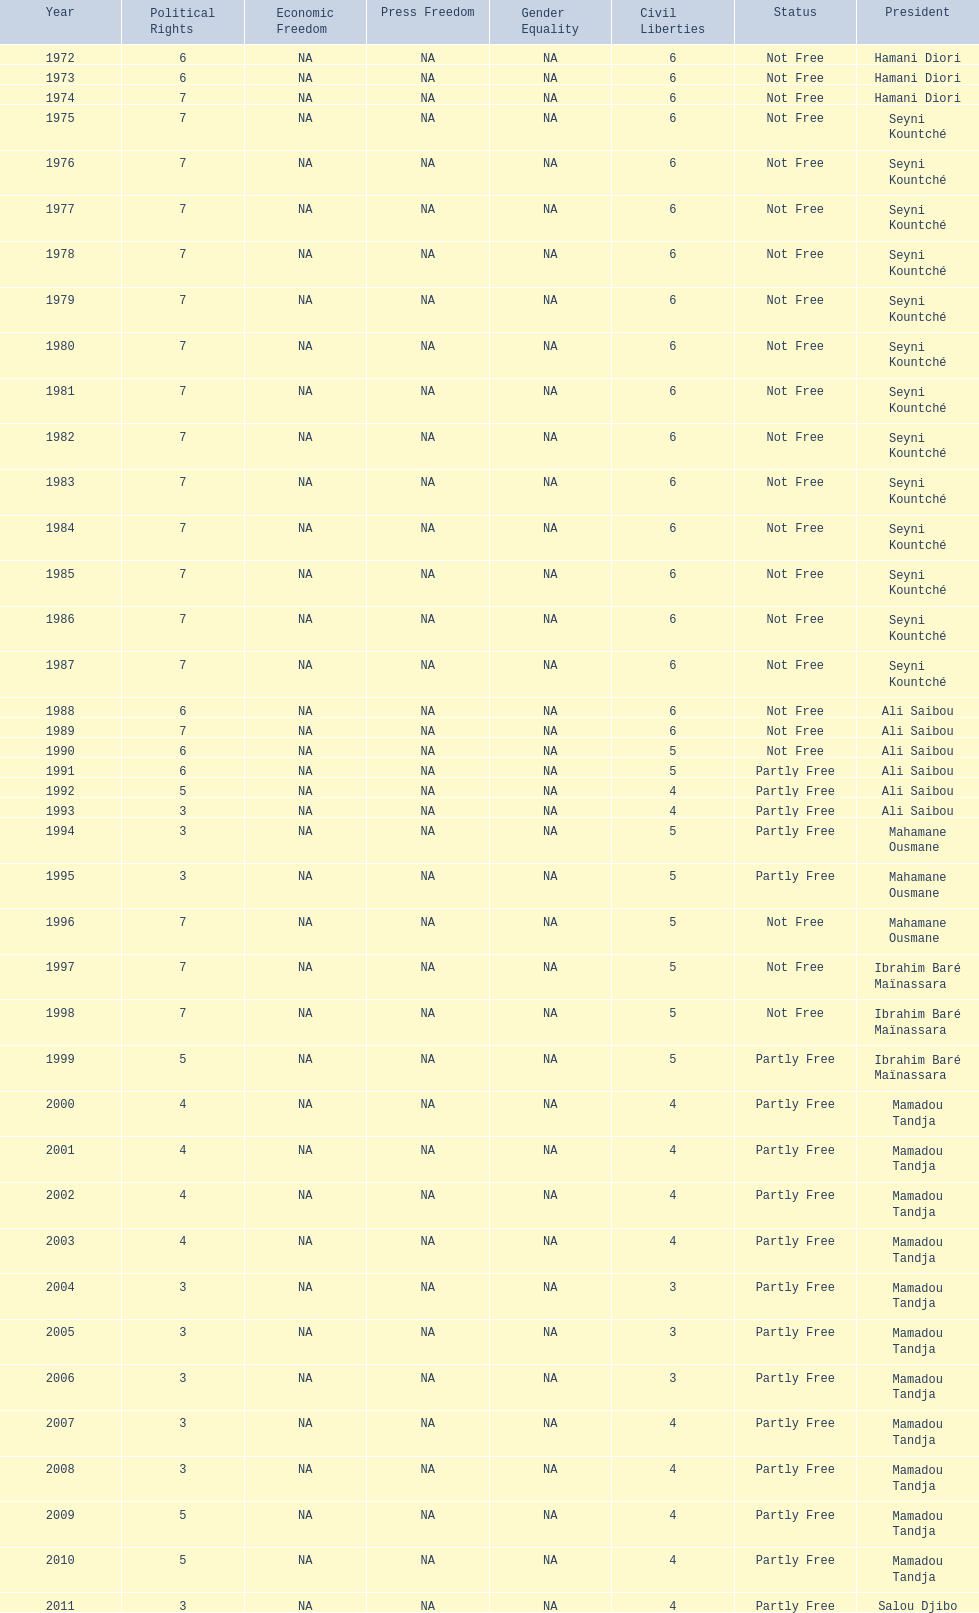Who is the next president listed after hamani diori in the year 1974? Seyni Kountché. 